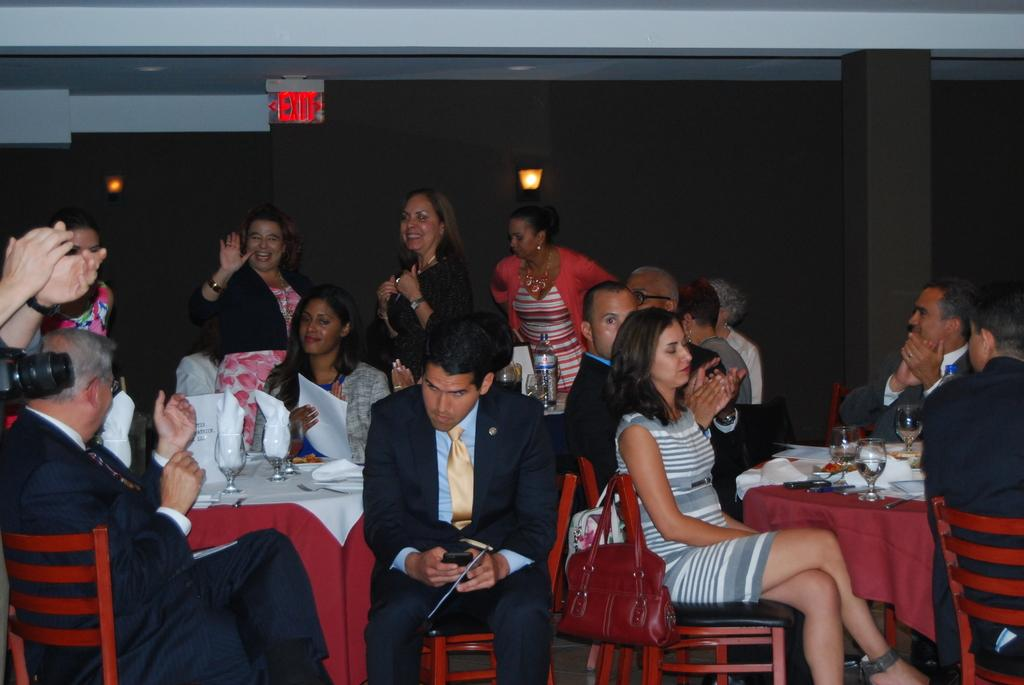<image>
Summarize the visual content of the image. People sitting at a table under a sign that says EXIT. 